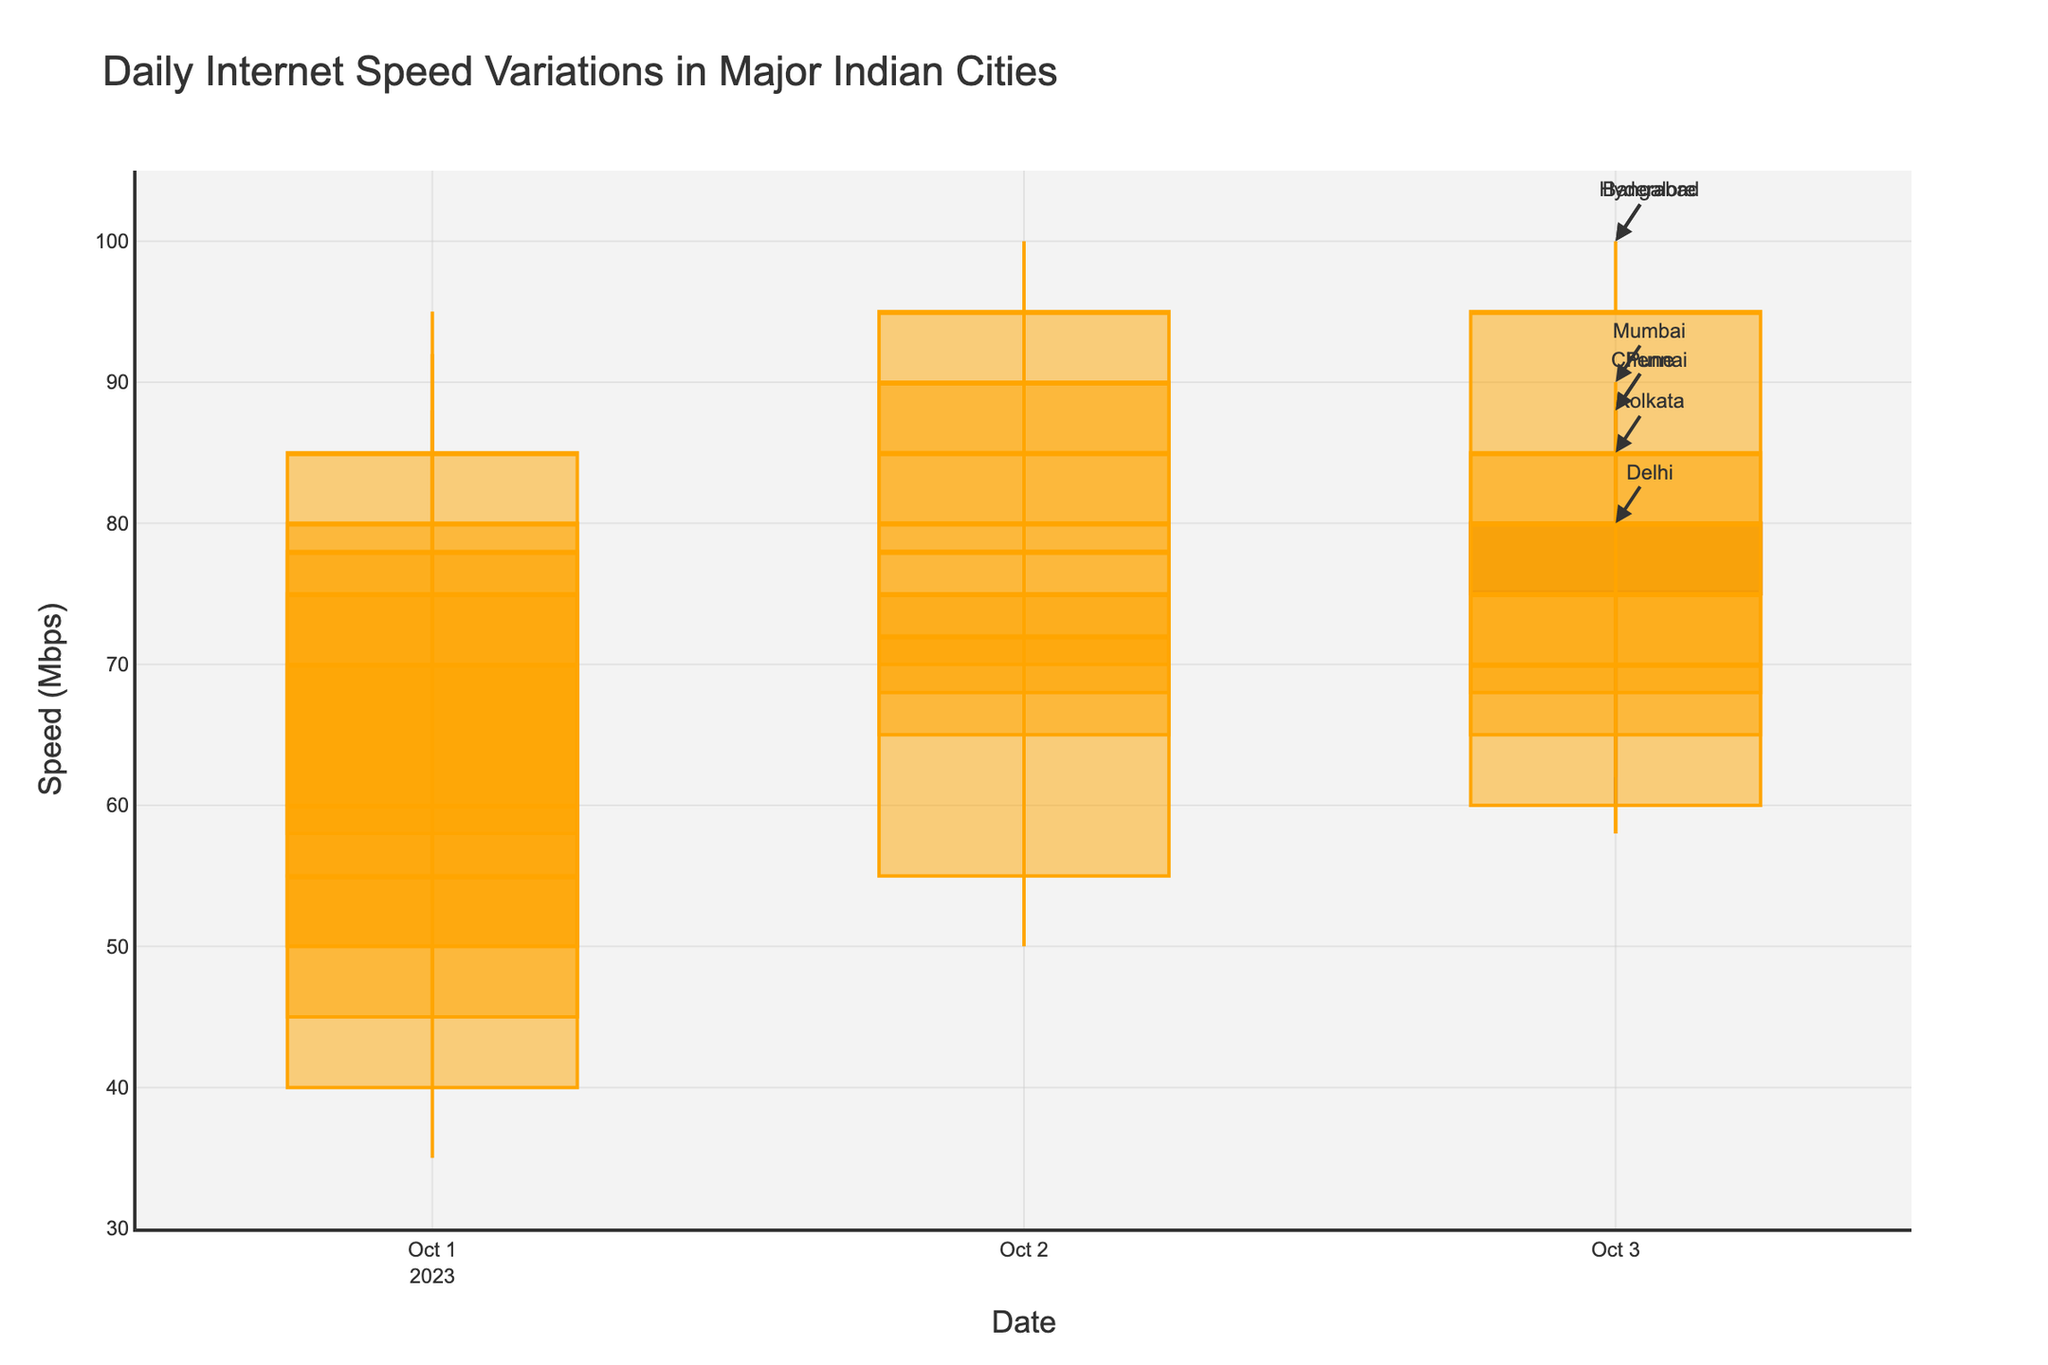What is the title of the figure? The title is usually positioned at the top of the chart. In this figure, the title provided is "Daily Internet Speed Variations in Major Indian Cities".
Answer: Daily Internet Speed Variations in Major Indian Cities Which city had the highest recorded internet speed, and what was the speed? To find the highest recorded speed, identify the maximum value in the 'High Speed (Mbps)' column and the corresponding city. Hyderabad on 2023-10-02 had a peak speed of 100 Mbps.
Answer: Hyderabad, 100 Mbps On 2023-10-03, which city had the smallest range between its high and low internet speeds? Calculate the range (High Speed - Low Speed) for each city on 2023-10-03. The smallest range is found by comparing these values. Chennai had the smallest range (82 - 58 = 24 Mbps).
Answer: Chennai In the three days' data shown, which city experienced the most significant drop in closing speeds? Compare the closing speeds from 2023-10-01 to 2023-10-03 for each city to determine the most significant drop. Mumbai had a closing speed drop from 75 Mbps to 75 Mbps (October 1 to 3), which is a decrease, considering its high on October 2.
Answer: Mumbai Which city displayed the most consistent internet speed (least variability in closing speeds) over the three days? Consistency can be determined by the least fluctuation in closing speeds across the dates. Calculate the variance or standard deviation of closing speeds for each city. Delhi had a closing speed consistency, fluctuating by a max of only 5 Mbps (55, 72, 70).
Answer: Delhi Which city had the greatest increase in open speed from October 1 to October 2? Compare the open speeds for each city between October 1 and October 2. Bangalore had the most significant increase from 55 to 80 Mbps, which is an increase of 25 Mbps.
Answer: Bangalore What is the average high speed for Mumbai over the three-day period? Calculate the average by summing the high speeds for Mumbai and dividing by the number of days (85 + 90 + 88) / 3 = 87.67 Mbps.
Answer: 87.67 Mbps 